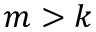<formula> <loc_0><loc_0><loc_500><loc_500>m > k</formula> 